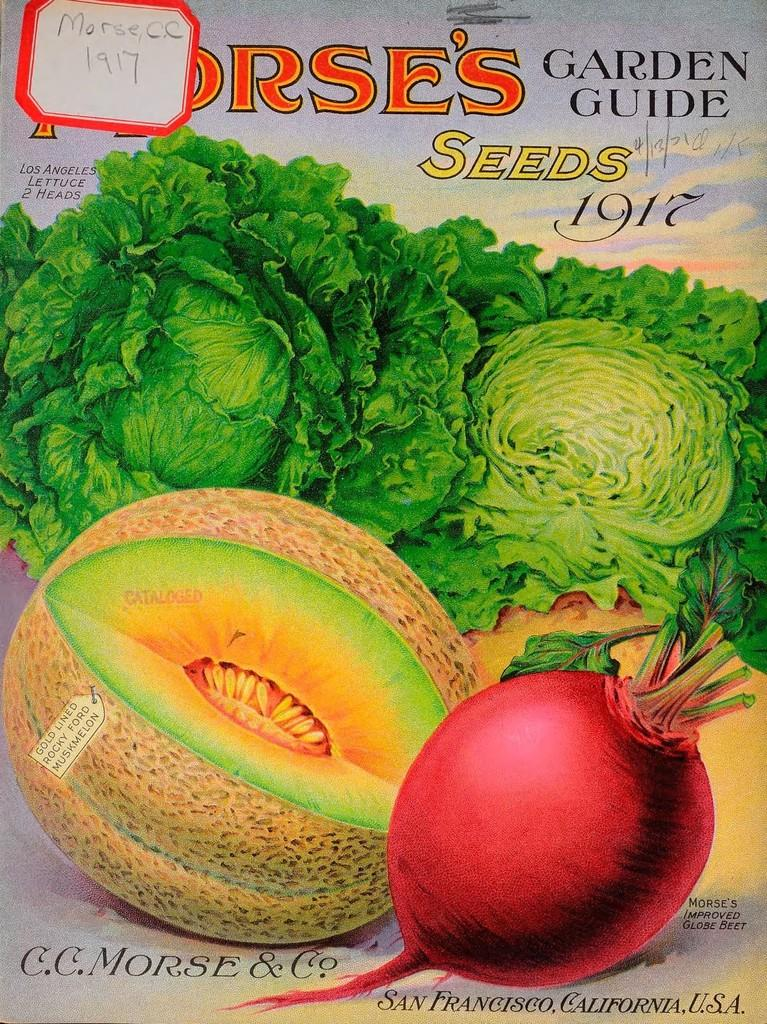What type of visual is the image? The image is a poster. What is depicted on the poster? There are pictures of vegetables on the poster. Are there any words or phrases on the poster? Yes, there are texts written on the poster. How does the poster provide a thrilling experience for the viewers? The poster does not provide a thrilling experience, as it only contains pictures of vegetables and texts. Can you see the poster flying in the image? No, the poster is not depicted as flying in the image; it is stationary. 